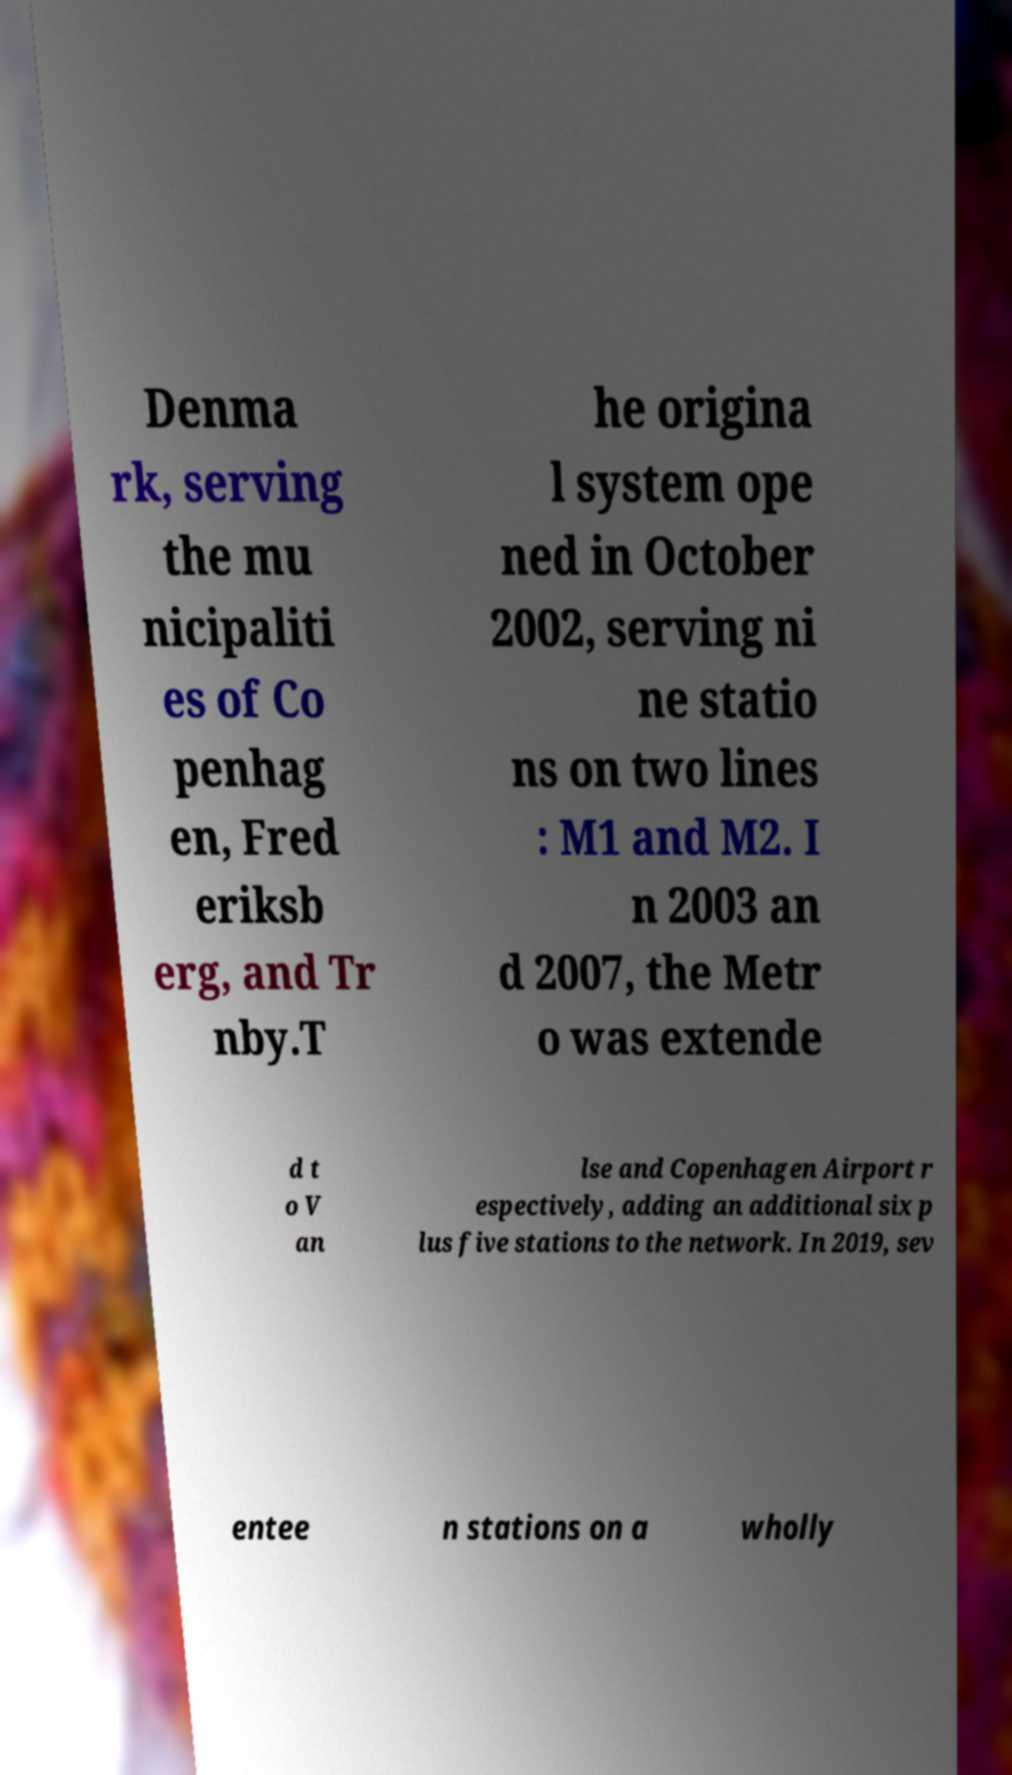Can you read and provide the text displayed in the image?This photo seems to have some interesting text. Can you extract and type it out for me? Denma rk, serving the mu nicipaliti es of Co penhag en, Fred eriksb erg, and Tr nby.T he origina l system ope ned in October 2002, serving ni ne statio ns on two lines : M1 and M2. I n 2003 an d 2007, the Metr o was extende d t o V an lse and Copenhagen Airport r espectively, adding an additional six p lus five stations to the network. In 2019, sev entee n stations on a wholly 